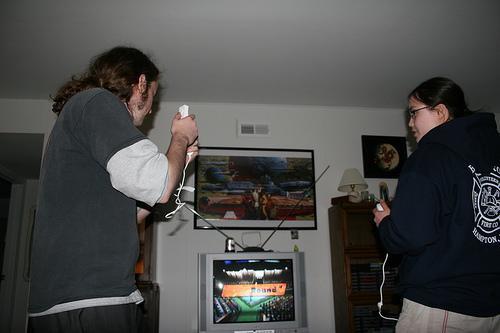Please mention two things that are hanging on the wall. A black framed painting and a white vent are hanging on the wall. Describe what the man wearing a white and gray shirt is doing. The man wearing a white and gray shirt is playing a Wii game. In the image, mention an accessory used by a person in the room. A pair of eye glasses is worn by a person in the room. List three objects placed on a high position from the ground. A lamp on top shelf, antenna on top of television, and white vent at top of ceiling. What type of electronic device is in the living room, and what's playing on its screen? A silver television is in the living room, and a video game is playing on the screen. Identify the color and type of the video game controller in the image. The video game controller is white and it is a Wii controller. For the visual entailment task, determine if a Wii control is in the hand of a person. Yes, a Wii control is in the hand of a person. For the multi-choice VQA task, which of the following objects/items is not in the image? A) silver television B) red bicycle C) white vent D) lamp on the bookcase Red bicycle For the product advertisement task, provide a catchy phrase featuring the main gaming device in the image. Experience endless fun and adventure with the incredible Wii controller - the gateway to a world of gaming! 